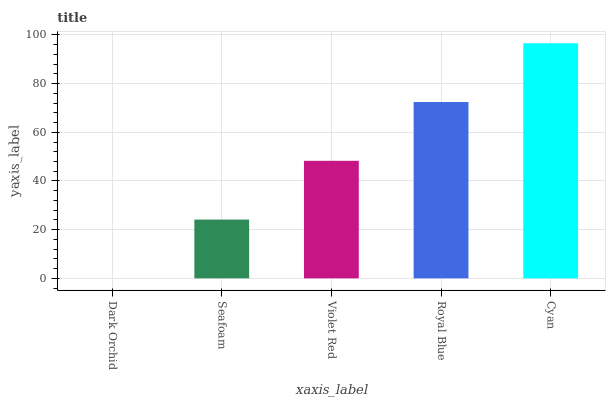Is Seafoam the minimum?
Answer yes or no. No. Is Seafoam the maximum?
Answer yes or no. No. Is Seafoam greater than Dark Orchid?
Answer yes or no. Yes. Is Dark Orchid less than Seafoam?
Answer yes or no. Yes. Is Dark Orchid greater than Seafoam?
Answer yes or no. No. Is Seafoam less than Dark Orchid?
Answer yes or no. No. Is Violet Red the high median?
Answer yes or no. Yes. Is Violet Red the low median?
Answer yes or no. Yes. Is Cyan the high median?
Answer yes or no. No. Is Dark Orchid the low median?
Answer yes or no. No. 